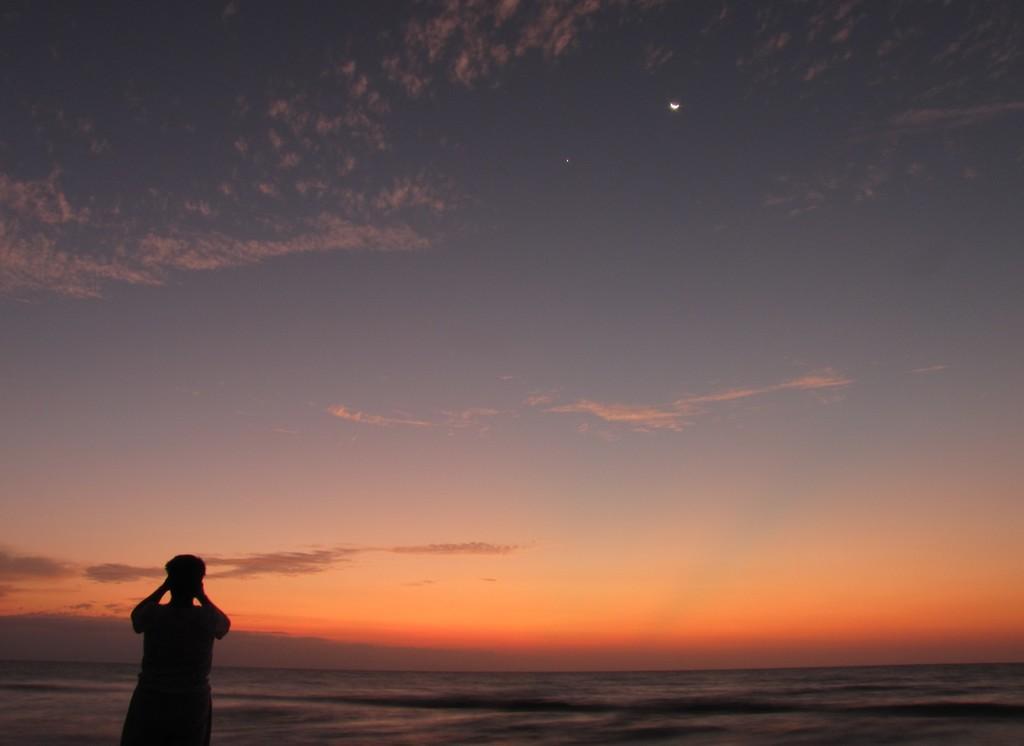How would you summarize this image in a sentence or two? In this image, we can see the sky. Left side bottom, we can see a person is standing. 